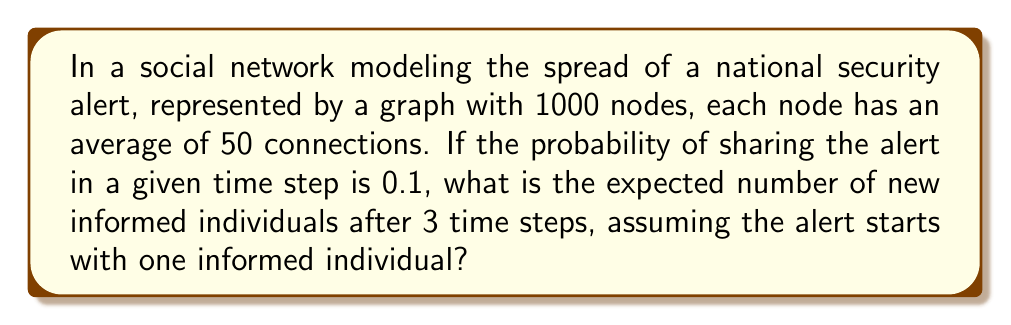Can you solve this math problem? Let's approach this step-by-step using concepts from graph theory and stochastic processes:

1) First, we need to model the spread of information as a branching process. In this case, we have a Galton-Watson process.

2) Let $Z_n$ be the number of informed individuals at time step $n$. We start with $Z_0 = 1$.

3) The expected number of new individuals informed by one person in one time step is:
   $\mu = 50 \cdot 0.1 = 5$

4) In a Galton-Watson process, the expected number of individuals after $n$ steps is given by:
   $E[Z_n] = \mu^n$

5) We want to find $E[Z_3] - 1$ (subtracting 1 to get only the new informed individuals):
   $E[Z_3] - 1 = \mu^3 - 1 = 5^3 - 1 = 124$

6) However, this assumes an infinite population. In our case, we have a finite population of 1000.

7) To account for this, we can use the approximation:
   $E[Z_n] \approx \min(N, \mu^n)$
   where $N$ is the total population.

8) In our case:
   $E[Z_3] \approx \min(1000, 5^3) = 125$

9) Therefore, the expected number of new informed individuals after 3 time steps is:
   $E[Z_3] - 1 = 125 - 1 = 124$
Answer: 124 